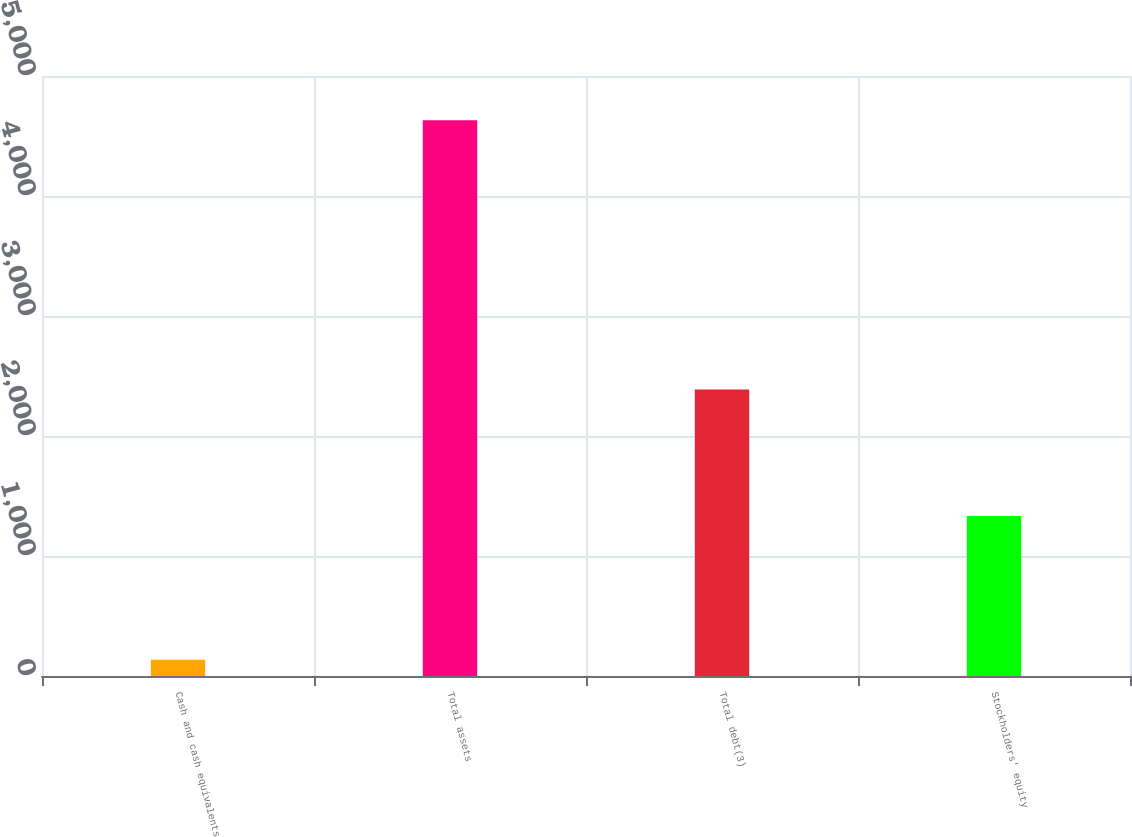Convert chart. <chart><loc_0><loc_0><loc_500><loc_500><bar_chart><fcel>Cash and cash equivalents<fcel>Total assets<fcel>Total debt(3)<fcel>Stockholders' equity<nl><fcel>135.1<fcel>4631.2<fcel>2387<fcel>1332.4<nl></chart> 